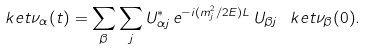Convert formula to latex. <formula><loc_0><loc_0><loc_500><loc_500>\ k e t { \nu _ { \alpha } ( t ) } = \sum _ { \beta } \sum _ { j } U ^ { * } _ { \alpha j } \, e ^ { - i ( m ^ { 2 } _ { j } / 2 E ) L } \, U _ { \beta j } \, \ k e t { \nu _ { \beta } ( 0 ) } .</formula> 